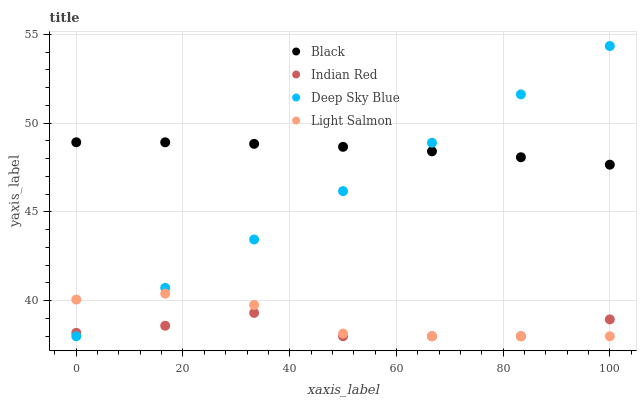Does Indian Red have the minimum area under the curve?
Answer yes or no. Yes. Does Black have the maximum area under the curve?
Answer yes or no. Yes. Does Deep Sky Blue have the minimum area under the curve?
Answer yes or no. No. Does Deep Sky Blue have the maximum area under the curve?
Answer yes or no. No. Is Deep Sky Blue the smoothest?
Answer yes or no. Yes. Is Indian Red the roughest?
Answer yes or no. Yes. Is Black the smoothest?
Answer yes or no. No. Is Black the roughest?
Answer yes or no. No. Does Light Salmon have the lowest value?
Answer yes or no. Yes. Does Black have the lowest value?
Answer yes or no. No. Does Deep Sky Blue have the highest value?
Answer yes or no. Yes. Does Black have the highest value?
Answer yes or no. No. Is Indian Red less than Black?
Answer yes or no. Yes. Is Black greater than Indian Red?
Answer yes or no. Yes. Does Indian Red intersect Deep Sky Blue?
Answer yes or no. Yes. Is Indian Red less than Deep Sky Blue?
Answer yes or no. No. Is Indian Red greater than Deep Sky Blue?
Answer yes or no. No. Does Indian Red intersect Black?
Answer yes or no. No. 